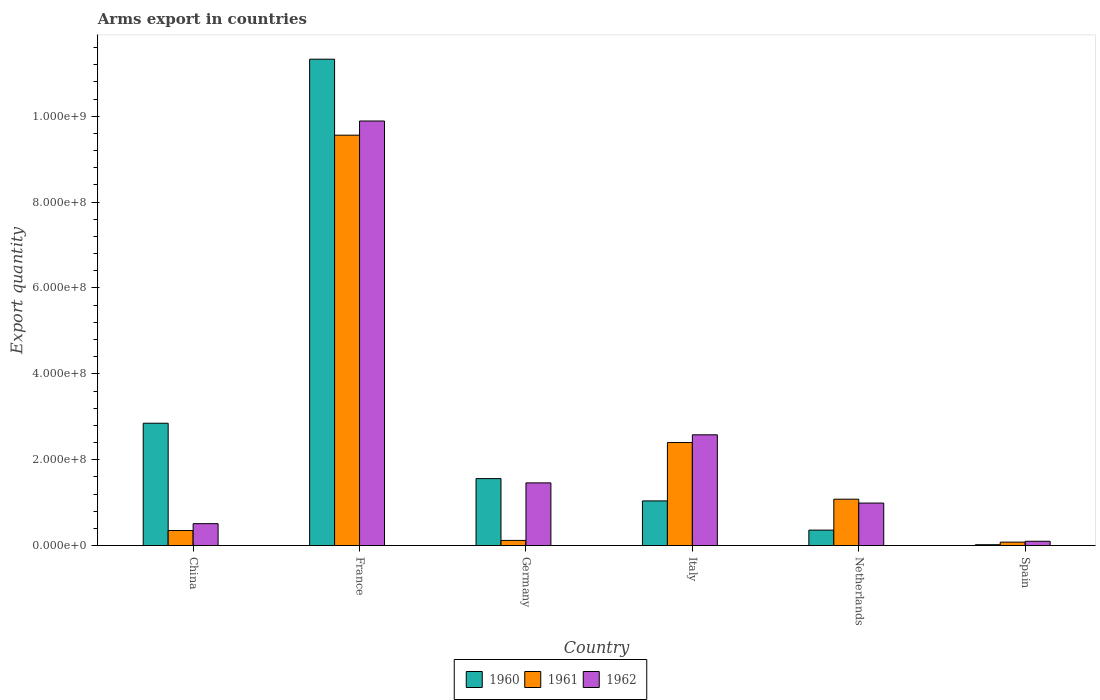How many different coloured bars are there?
Make the answer very short. 3. How many groups of bars are there?
Keep it short and to the point. 6. Are the number of bars on each tick of the X-axis equal?
Provide a short and direct response. Yes. How many bars are there on the 1st tick from the left?
Provide a short and direct response. 3. In how many cases, is the number of bars for a given country not equal to the number of legend labels?
Offer a terse response. 0. What is the total arms export in 1960 in Netherlands?
Your response must be concise. 3.60e+07. Across all countries, what is the maximum total arms export in 1962?
Make the answer very short. 9.89e+08. What is the total total arms export in 1962 in the graph?
Provide a short and direct response. 1.55e+09. What is the difference between the total arms export in 1962 in China and that in Netherlands?
Provide a succinct answer. -4.80e+07. What is the difference between the total arms export in 1962 in China and the total arms export in 1961 in Spain?
Your response must be concise. 4.30e+07. What is the average total arms export in 1962 per country?
Your response must be concise. 2.59e+08. What is the difference between the total arms export of/in 1962 and total arms export of/in 1960 in Netherlands?
Your answer should be very brief. 6.30e+07. What is the ratio of the total arms export in 1960 in France to that in Italy?
Provide a short and direct response. 10.89. Is the total arms export in 1962 in Italy less than that in Spain?
Make the answer very short. No. What is the difference between the highest and the second highest total arms export in 1960?
Your answer should be very brief. 9.77e+08. What is the difference between the highest and the lowest total arms export in 1960?
Provide a succinct answer. 1.13e+09. What does the 2nd bar from the left in Netherlands represents?
Your response must be concise. 1961. What does the 1st bar from the right in China represents?
Make the answer very short. 1962. How many countries are there in the graph?
Your answer should be very brief. 6. What is the difference between two consecutive major ticks on the Y-axis?
Ensure brevity in your answer.  2.00e+08. Does the graph contain grids?
Make the answer very short. No. Where does the legend appear in the graph?
Provide a succinct answer. Bottom center. What is the title of the graph?
Offer a terse response. Arms export in countries. What is the label or title of the Y-axis?
Offer a very short reply. Export quantity. What is the Export quantity in 1960 in China?
Keep it short and to the point. 2.85e+08. What is the Export quantity in 1961 in China?
Provide a succinct answer. 3.50e+07. What is the Export quantity of 1962 in China?
Your response must be concise. 5.10e+07. What is the Export quantity of 1960 in France?
Keep it short and to the point. 1.13e+09. What is the Export quantity in 1961 in France?
Make the answer very short. 9.56e+08. What is the Export quantity of 1962 in France?
Offer a terse response. 9.89e+08. What is the Export quantity of 1960 in Germany?
Offer a very short reply. 1.56e+08. What is the Export quantity of 1961 in Germany?
Make the answer very short. 1.20e+07. What is the Export quantity of 1962 in Germany?
Keep it short and to the point. 1.46e+08. What is the Export quantity in 1960 in Italy?
Offer a terse response. 1.04e+08. What is the Export quantity of 1961 in Italy?
Make the answer very short. 2.40e+08. What is the Export quantity of 1962 in Italy?
Provide a succinct answer. 2.58e+08. What is the Export quantity in 1960 in Netherlands?
Provide a short and direct response. 3.60e+07. What is the Export quantity in 1961 in Netherlands?
Keep it short and to the point. 1.08e+08. What is the Export quantity of 1962 in Netherlands?
Give a very brief answer. 9.90e+07. What is the Export quantity of 1960 in Spain?
Provide a short and direct response. 2.00e+06. Across all countries, what is the maximum Export quantity of 1960?
Give a very brief answer. 1.13e+09. Across all countries, what is the maximum Export quantity of 1961?
Ensure brevity in your answer.  9.56e+08. Across all countries, what is the maximum Export quantity in 1962?
Provide a succinct answer. 9.89e+08. Across all countries, what is the minimum Export quantity of 1961?
Make the answer very short. 8.00e+06. What is the total Export quantity in 1960 in the graph?
Keep it short and to the point. 1.72e+09. What is the total Export quantity in 1961 in the graph?
Offer a terse response. 1.36e+09. What is the total Export quantity in 1962 in the graph?
Your answer should be compact. 1.55e+09. What is the difference between the Export quantity in 1960 in China and that in France?
Your answer should be very brief. -8.48e+08. What is the difference between the Export quantity of 1961 in China and that in France?
Give a very brief answer. -9.21e+08. What is the difference between the Export quantity of 1962 in China and that in France?
Provide a short and direct response. -9.38e+08. What is the difference between the Export quantity in 1960 in China and that in Germany?
Make the answer very short. 1.29e+08. What is the difference between the Export quantity in 1961 in China and that in Germany?
Provide a short and direct response. 2.30e+07. What is the difference between the Export quantity in 1962 in China and that in Germany?
Your answer should be compact. -9.50e+07. What is the difference between the Export quantity in 1960 in China and that in Italy?
Offer a terse response. 1.81e+08. What is the difference between the Export quantity of 1961 in China and that in Italy?
Offer a terse response. -2.05e+08. What is the difference between the Export quantity in 1962 in China and that in Italy?
Provide a succinct answer. -2.07e+08. What is the difference between the Export quantity in 1960 in China and that in Netherlands?
Your answer should be very brief. 2.49e+08. What is the difference between the Export quantity of 1961 in China and that in Netherlands?
Ensure brevity in your answer.  -7.30e+07. What is the difference between the Export quantity of 1962 in China and that in Netherlands?
Keep it short and to the point. -4.80e+07. What is the difference between the Export quantity in 1960 in China and that in Spain?
Ensure brevity in your answer.  2.83e+08. What is the difference between the Export quantity of 1961 in China and that in Spain?
Your answer should be very brief. 2.70e+07. What is the difference between the Export quantity of 1962 in China and that in Spain?
Offer a terse response. 4.10e+07. What is the difference between the Export quantity in 1960 in France and that in Germany?
Offer a terse response. 9.77e+08. What is the difference between the Export quantity in 1961 in France and that in Germany?
Offer a terse response. 9.44e+08. What is the difference between the Export quantity in 1962 in France and that in Germany?
Make the answer very short. 8.43e+08. What is the difference between the Export quantity in 1960 in France and that in Italy?
Provide a succinct answer. 1.03e+09. What is the difference between the Export quantity of 1961 in France and that in Italy?
Your answer should be very brief. 7.16e+08. What is the difference between the Export quantity in 1962 in France and that in Italy?
Keep it short and to the point. 7.31e+08. What is the difference between the Export quantity of 1960 in France and that in Netherlands?
Your response must be concise. 1.10e+09. What is the difference between the Export quantity of 1961 in France and that in Netherlands?
Offer a very short reply. 8.48e+08. What is the difference between the Export quantity of 1962 in France and that in Netherlands?
Provide a succinct answer. 8.90e+08. What is the difference between the Export quantity of 1960 in France and that in Spain?
Your response must be concise. 1.13e+09. What is the difference between the Export quantity in 1961 in France and that in Spain?
Ensure brevity in your answer.  9.48e+08. What is the difference between the Export quantity of 1962 in France and that in Spain?
Give a very brief answer. 9.79e+08. What is the difference between the Export quantity of 1960 in Germany and that in Italy?
Your answer should be very brief. 5.20e+07. What is the difference between the Export quantity of 1961 in Germany and that in Italy?
Your answer should be very brief. -2.28e+08. What is the difference between the Export quantity of 1962 in Germany and that in Italy?
Give a very brief answer. -1.12e+08. What is the difference between the Export quantity in 1960 in Germany and that in Netherlands?
Make the answer very short. 1.20e+08. What is the difference between the Export quantity in 1961 in Germany and that in Netherlands?
Make the answer very short. -9.60e+07. What is the difference between the Export quantity of 1962 in Germany and that in Netherlands?
Your answer should be very brief. 4.70e+07. What is the difference between the Export quantity in 1960 in Germany and that in Spain?
Ensure brevity in your answer.  1.54e+08. What is the difference between the Export quantity of 1961 in Germany and that in Spain?
Ensure brevity in your answer.  4.00e+06. What is the difference between the Export quantity of 1962 in Germany and that in Spain?
Make the answer very short. 1.36e+08. What is the difference between the Export quantity of 1960 in Italy and that in Netherlands?
Your answer should be compact. 6.80e+07. What is the difference between the Export quantity in 1961 in Italy and that in Netherlands?
Your answer should be very brief. 1.32e+08. What is the difference between the Export quantity in 1962 in Italy and that in Netherlands?
Offer a very short reply. 1.59e+08. What is the difference between the Export quantity in 1960 in Italy and that in Spain?
Your response must be concise. 1.02e+08. What is the difference between the Export quantity in 1961 in Italy and that in Spain?
Offer a very short reply. 2.32e+08. What is the difference between the Export quantity of 1962 in Italy and that in Spain?
Provide a succinct answer. 2.48e+08. What is the difference between the Export quantity of 1960 in Netherlands and that in Spain?
Your answer should be very brief. 3.40e+07. What is the difference between the Export quantity of 1961 in Netherlands and that in Spain?
Offer a very short reply. 1.00e+08. What is the difference between the Export quantity of 1962 in Netherlands and that in Spain?
Your answer should be compact. 8.90e+07. What is the difference between the Export quantity in 1960 in China and the Export quantity in 1961 in France?
Ensure brevity in your answer.  -6.71e+08. What is the difference between the Export quantity of 1960 in China and the Export quantity of 1962 in France?
Keep it short and to the point. -7.04e+08. What is the difference between the Export quantity in 1961 in China and the Export quantity in 1962 in France?
Your answer should be very brief. -9.54e+08. What is the difference between the Export quantity of 1960 in China and the Export quantity of 1961 in Germany?
Your response must be concise. 2.73e+08. What is the difference between the Export quantity of 1960 in China and the Export quantity of 1962 in Germany?
Keep it short and to the point. 1.39e+08. What is the difference between the Export quantity in 1961 in China and the Export quantity in 1962 in Germany?
Offer a very short reply. -1.11e+08. What is the difference between the Export quantity in 1960 in China and the Export quantity in 1961 in Italy?
Offer a terse response. 4.50e+07. What is the difference between the Export quantity of 1960 in China and the Export quantity of 1962 in Italy?
Provide a succinct answer. 2.70e+07. What is the difference between the Export quantity of 1961 in China and the Export quantity of 1962 in Italy?
Keep it short and to the point. -2.23e+08. What is the difference between the Export quantity in 1960 in China and the Export quantity in 1961 in Netherlands?
Offer a terse response. 1.77e+08. What is the difference between the Export quantity of 1960 in China and the Export quantity of 1962 in Netherlands?
Keep it short and to the point. 1.86e+08. What is the difference between the Export quantity in 1961 in China and the Export quantity in 1962 in Netherlands?
Offer a very short reply. -6.40e+07. What is the difference between the Export quantity of 1960 in China and the Export quantity of 1961 in Spain?
Your response must be concise. 2.77e+08. What is the difference between the Export quantity of 1960 in China and the Export quantity of 1962 in Spain?
Provide a short and direct response. 2.75e+08. What is the difference between the Export quantity of 1961 in China and the Export quantity of 1962 in Spain?
Your response must be concise. 2.50e+07. What is the difference between the Export quantity in 1960 in France and the Export quantity in 1961 in Germany?
Ensure brevity in your answer.  1.12e+09. What is the difference between the Export quantity of 1960 in France and the Export quantity of 1962 in Germany?
Your response must be concise. 9.87e+08. What is the difference between the Export quantity in 1961 in France and the Export quantity in 1962 in Germany?
Offer a terse response. 8.10e+08. What is the difference between the Export quantity in 1960 in France and the Export quantity in 1961 in Italy?
Make the answer very short. 8.93e+08. What is the difference between the Export quantity in 1960 in France and the Export quantity in 1962 in Italy?
Provide a short and direct response. 8.75e+08. What is the difference between the Export quantity in 1961 in France and the Export quantity in 1962 in Italy?
Your answer should be very brief. 6.98e+08. What is the difference between the Export quantity in 1960 in France and the Export quantity in 1961 in Netherlands?
Your answer should be compact. 1.02e+09. What is the difference between the Export quantity of 1960 in France and the Export quantity of 1962 in Netherlands?
Provide a succinct answer. 1.03e+09. What is the difference between the Export quantity in 1961 in France and the Export quantity in 1962 in Netherlands?
Your answer should be compact. 8.57e+08. What is the difference between the Export quantity in 1960 in France and the Export quantity in 1961 in Spain?
Offer a terse response. 1.12e+09. What is the difference between the Export quantity of 1960 in France and the Export quantity of 1962 in Spain?
Your answer should be very brief. 1.12e+09. What is the difference between the Export quantity of 1961 in France and the Export quantity of 1962 in Spain?
Your answer should be very brief. 9.46e+08. What is the difference between the Export quantity in 1960 in Germany and the Export quantity in 1961 in Italy?
Provide a short and direct response. -8.40e+07. What is the difference between the Export quantity of 1960 in Germany and the Export quantity of 1962 in Italy?
Offer a terse response. -1.02e+08. What is the difference between the Export quantity in 1961 in Germany and the Export quantity in 1962 in Italy?
Give a very brief answer. -2.46e+08. What is the difference between the Export quantity of 1960 in Germany and the Export quantity of 1961 in Netherlands?
Your response must be concise. 4.80e+07. What is the difference between the Export quantity in 1960 in Germany and the Export quantity in 1962 in Netherlands?
Offer a very short reply. 5.70e+07. What is the difference between the Export quantity in 1961 in Germany and the Export quantity in 1962 in Netherlands?
Provide a short and direct response. -8.70e+07. What is the difference between the Export quantity of 1960 in Germany and the Export quantity of 1961 in Spain?
Provide a short and direct response. 1.48e+08. What is the difference between the Export quantity of 1960 in Germany and the Export quantity of 1962 in Spain?
Give a very brief answer. 1.46e+08. What is the difference between the Export quantity in 1961 in Italy and the Export quantity in 1962 in Netherlands?
Make the answer very short. 1.41e+08. What is the difference between the Export quantity in 1960 in Italy and the Export quantity in 1961 in Spain?
Provide a short and direct response. 9.60e+07. What is the difference between the Export quantity of 1960 in Italy and the Export quantity of 1962 in Spain?
Ensure brevity in your answer.  9.40e+07. What is the difference between the Export quantity of 1961 in Italy and the Export quantity of 1962 in Spain?
Ensure brevity in your answer.  2.30e+08. What is the difference between the Export quantity of 1960 in Netherlands and the Export quantity of 1961 in Spain?
Keep it short and to the point. 2.80e+07. What is the difference between the Export quantity of 1960 in Netherlands and the Export quantity of 1962 in Spain?
Provide a succinct answer. 2.60e+07. What is the difference between the Export quantity in 1961 in Netherlands and the Export quantity in 1962 in Spain?
Provide a succinct answer. 9.80e+07. What is the average Export quantity in 1960 per country?
Ensure brevity in your answer.  2.86e+08. What is the average Export quantity of 1961 per country?
Keep it short and to the point. 2.26e+08. What is the average Export quantity of 1962 per country?
Offer a terse response. 2.59e+08. What is the difference between the Export quantity in 1960 and Export quantity in 1961 in China?
Keep it short and to the point. 2.50e+08. What is the difference between the Export quantity in 1960 and Export quantity in 1962 in China?
Ensure brevity in your answer.  2.34e+08. What is the difference between the Export quantity of 1961 and Export quantity of 1962 in China?
Give a very brief answer. -1.60e+07. What is the difference between the Export quantity of 1960 and Export quantity of 1961 in France?
Your answer should be compact. 1.77e+08. What is the difference between the Export quantity of 1960 and Export quantity of 1962 in France?
Offer a very short reply. 1.44e+08. What is the difference between the Export quantity of 1961 and Export quantity of 1962 in France?
Your answer should be compact. -3.30e+07. What is the difference between the Export quantity of 1960 and Export quantity of 1961 in Germany?
Your answer should be very brief. 1.44e+08. What is the difference between the Export quantity of 1961 and Export quantity of 1962 in Germany?
Keep it short and to the point. -1.34e+08. What is the difference between the Export quantity in 1960 and Export quantity in 1961 in Italy?
Your response must be concise. -1.36e+08. What is the difference between the Export quantity in 1960 and Export quantity in 1962 in Italy?
Provide a succinct answer. -1.54e+08. What is the difference between the Export quantity in 1961 and Export quantity in 1962 in Italy?
Offer a terse response. -1.80e+07. What is the difference between the Export quantity of 1960 and Export quantity of 1961 in Netherlands?
Offer a very short reply. -7.20e+07. What is the difference between the Export quantity in 1960 and Export quantity in 1962 in Netherlands?
Keep it short and to the point. -6.30e+07. What is the difference between the Export quantity in 1961 and Export quantity in 1962 in Netherlands?
Offer a terse response. 9.00e+06. What is the difference between the Export quantity of 1960 and Export quantity of 1961 in Spain?
Provide a succinct answer. -6.00e+06. What is the difference between the Export quantity of 1960 and Export quantity of 1962 in Spain?
Offer a very short reply. -8.00e+06. What is the ratio of the Export quantity in 1960 in China to that in France?
Offer a very short reply. 0.25. What is the ratio of the Export quantity of 1961 in China to that in France?
Ensure brevity in your answer.  0.04. What is the ratio of the Export quantity in 1962 in China to that in France?
Your answer should be very brief. 0.05. What is the ratio of the Export quantity in 1960 in China to that in Germany?
Offer a very short reply. 1.83. What is the ratio of the Export quantity of 1961 in China to that in Germany?
Give a very brief answer. 2.92. What is the ratio of the Export quantity in 1962 in China to that in Germany?
Make the answer very short. 0.35. What is the ratio of the Export quantity in 1960 in China to that in Italy?
Make the answer very short. 2.74. What is the ratio of the Export quantity in 1961 in China to that in Italy?
Offer a terse response. 0.15. What is the ratio of the Export quantity of 1962 in China to that in Italy?
Offer a very short reply. 0.2. What is the ratio of the Export quantity of 1960 in China to that in Netherlands?
Give a very brief answer. 7.92. What is the ratio of the Export quantity of 1961 in China to that in Netherlands?
Your answer should be very brief. 0.32. What is the ratio of the Export quantity in 1962 in China to that in Netherlands?
Provide a succinct answer. 0.52. What is the ratio of the Export quantity in 1960 in China to that in Spain?
Make the answer very short. 142.5. What is the ratio of the Export quantity in 1961 in China to that in Spain?
Give a very brief answer. 4.38. What is the ratio of the Export quantity of 1960 in France to that in Germany?
Keep it short and to the point. 7.26. What is the ratio of the Export quantity in 1961 in France to that in Germany?
Make the answer very short. 79.67. What is the ratio of the Export quantity of 1962 in France to that in Germany?
Your response must be concise. 6.77. What is the ratio of the Export quantity in 1960 in France to that in Italy?
Provide a short and direct response. 10.89. What is the ratio of the Export quantity in 1961 in France to that in Italy?
Your answer should be compact. 3.98. What is the ratio of the Export quantity of 1962 in France to that in Italy?
Give a very brief answer. 3.83. What is the ratio of the Export quantity in 1960 in France to that in Netherlands?
Give a very brief answer. 31.47. What is the ratio of the Export quantity in 1961 in France to that in Netherlands?
Your response must be concise. 8.85. What is the ratio of the Export quantity of 1962 in France to that in Netherlands?
Your response must be concise. 9.99. What is the ratio of the Export quantity of 1960 in France to that in Spain?
Provide a succinct answer. 566.5. What is the ratio of the Export quantity in 1961 in France to that in Spain?
Give a very brief answer. 119.5. What is the ratio of the Export quantity of 1962 in France to that in Spain?
Provide a succinct answer. 98.9. What is the ratio of the Export quantity of 1961 in Germany to that in Italy?
Offer a terse response. 0.05. What is the ratio of the Export quantity in 1962 in Germany to that in Italy?
Provide a succinct answer. 0.57. What is the ratio of the Export quantity in 1960 in Germany to that in Netherlands?
Ensure brevity in your answer.  4.33. What is the ratio of the Export quantity of 1961 in Germany to that in Netherlands?
Ensure brevity in your answer.  0.11. What is the ratio of the Export quantity in 1962 in Germany to that in Netherlands?
Provide a short and direct response. 1.47. What is the ratio of the Export quantity of 1961 in Germany to that in Spain?
Your response must be concise. 1.5. What is the ratio of the Export quantity in 1962 in Germany to that in Spain?
Provide a short and direct response. 14.6. What is the ratio of the Export quantity in 1960 in Italy to that in Netherlands?
Give a very brief answer. 2.89. What is the ratio of the Export quantity in 1961 in Italy to that in Netherlands?
Give a very brief answer. 2.22. What is the ratio of the Export quantity of 1962 in Italy to that in Netherlands?
Give a very brief answer. 2.61. What is the ratio of the Export quantity of 1960 in Italy to that in Spain?
Your answer should be compact. 52. What is the ratio of the Export quantity of 1962 in Italy to that in Spain?
Your answer should be very brief. 25.8. What is the ratio of the Export quantity of 1960 in Netherlands to that in Spain?
Your answer should be very brief. 18. What is the difference between the highest and the second highest Export quantity of 1960?
Your answer should be very brief. 8.48e+08. What is the difference between the highest and the second highest Export quantity of 1961?
Give a very brief answer. 7.16e+08. What is the difference between the highest and the second highest Export quantity of 1962?
Provide a succinct answer. 7.31e+08. What is the difference between the highest and the lowest Export quantity of 1960?
Ensure brevity in your answer.  1.13e+09. What is the difference between the highest and the lowest Export quantity of 1961?
Provide a succinct answer. 9.48e+08. What is the difference between the highest and the lowest Export quantity of 1962?
Keep it short and to the point. 9.79e+08. 